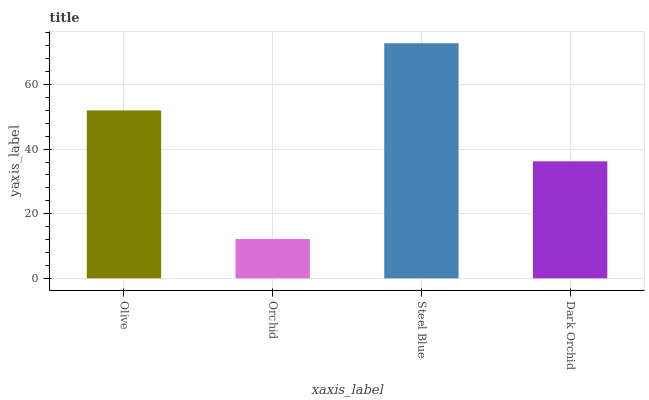Is Orchid the minimum?
Answer yes or no. Yes. Is Steel Blue the maximum?
Answer yes or no. Yes. Is Steel Blue the minimum?
Answer yes or no. No. Is Orchid the maximum?
Answer yes or no. No. Is Steel Blue greater than Orchid?
Answer yes or no. Yes. Is Orchid less than Steel Blue?
Answer yes or no. Yes. Is Orchid greater than Steel Blue?
Answer yes or no. No. Is Steel Blue less than Orchid?
Answer yes or no. No. Is Olive the high median?
Answer yes or no. Yes. Is Dark Orchid the low median?
Answer yes or no. Yes. Is Steel Blue the high median?
Answer yes or no. No. Is Orchid the low median?
Answer yes or no. No. 